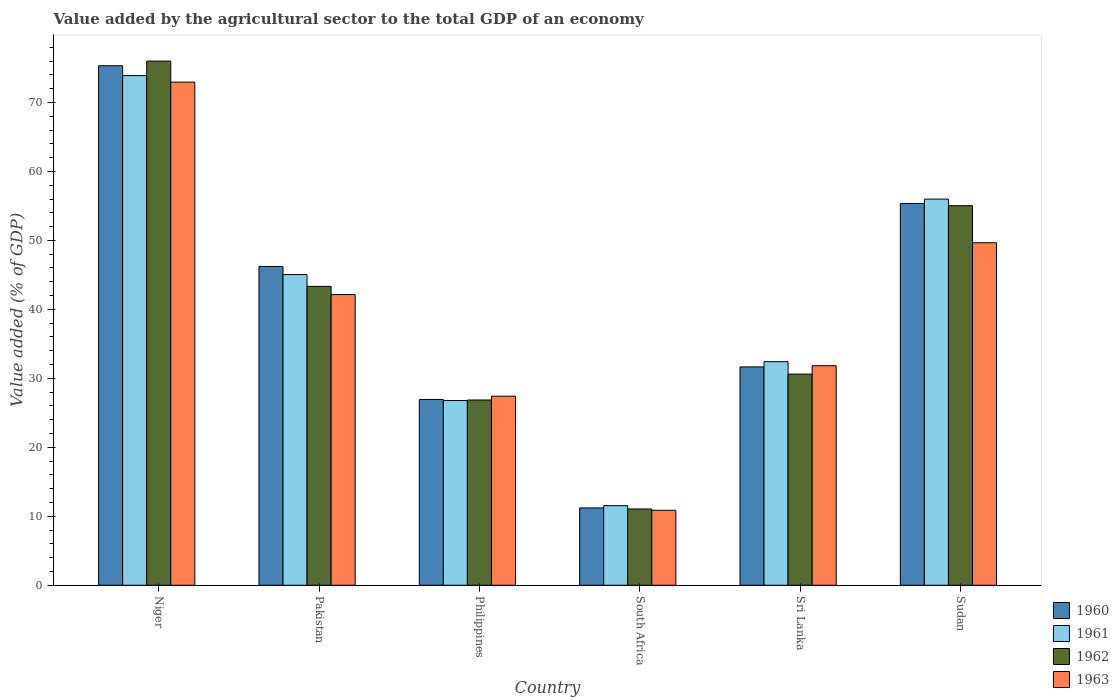Are the number of bars on each tick of the X-axis equal?
Give a very brief answer. Yes. How many bars are there on the 5th tick from the left?
Provide a short and direct response. 4. How many bars are there on the 6th tick from the right?
Your answer should be very brief. 4. What is the label of the 1st group of bars from the left?
Keep it short and to the point. Niger. What is the value added by the agricultural sector to the total GDP in 1961 in South Africa?
Provide a succinct answer. 11.54. Across all countries, what is the maximum value added by the agricultural sector to the total GDP in 1961?
Give a very brief answer. 73.89. Across all countries, what is the minimum value added by the agricultural sector to the total GDP in 1963?
Keep it short and to the point. 10.87. In which country was the value added by the agricultural sector to the total GDP in 1961 maximum?
Offer a very short reply. Niger. In which country was the value added by the agricultural sector to the total GDP in 1961 minimum?
Your answer should be compact. South Africa. What is the total value added by the agricultural sector to the total GDP in 1960 in the graph?
Offer a very short reply. 246.7. What is the difference between the value added by the agricultural sector to the total GDP in 1960 in Philippines and that in Sudan?
Offer a terse response. -28.41. What is the difference between the value added by the agricultural sector to the total GDP in 1961 in Pakistan and the value added by the agricultural sector to the total GDP in 1960 in South Africa?
Ensure brevity in your answer.  33.83. What is the average value added by the agricultural sector to the total GDP in 1961 per country?
Your answer should be very brief. 40.94. What is the difference between the value added by the agricultural sector to the total GDP of/in 1961 and value added by the agricultural sector to the total GDP of/in 1962 in Philippines?
Your answer should be compact. -0.08. In how many countries, is the value added by the agricultural sector to the total GDP in 1960 greater than 72 %?
Your answer should be compact. 1. What is the ratio of the value added by the agricultural sector to the total GDP in 1962 in Niger to that in Philippines?
Your answer should be very brief. 2.83. Is the difference between the value added by the agricultural sector to the total GDP in 1961 in Niger and Philippines greater than the difference between the value added by the agricultural sector to the total GDP in 1962 in Niger and Philippines?
Offer a very short reply. No. What is the difference between the highest and the second highest value added by the agricultural sector to the total GDP in 1963?
Keep it short and to the point. 23.29. What is the difference between the highest and the lowest value added by the agricultural sector to the total GDP in 1963?
Keep it short and to the point. 62.08. Is it the case that in every country, the sum of the value added by the agricultural sector to the total GDP in 1962 and value added by the agricultural sector to the total GDP in 1963 is greater than the sum of value added by the agricultural sector to the total GDP in 1961 and value added by the agricultural sector to the total GDP in 1960?
Give a very brief answer. No. How many countries are there in the graph?
Ensure brevity in your answer.  6. What is the difference between two consecutive major ticks on the Y-axis?
Your response must be concise. 10. Does the graph contain any zero values?
Provide a short and direct response. No. Does the graph contain grids?
Provide a short and direct response. No. How many legend labels are there?
Your response must be concise. 4. What is the title of the graph?
Your answer should be very brief. Value added by the agricultural sector to the total GDP of an economy. What is the label or title of the X-axis?
Provide a succinct answer. Country. What is the label or title of the Y-axis?
Ensure brevity in your answer.  Value added (% of GDP). What is the Value added (% of GDP) of 1960 in Niger?
Keep it short and to the point. 75.32. What is the Value added (% of GDP) of 1961 in Niger?
Offer a very short reply. 73.89. What is the Value added (% of GDP) in 1962 in Niger?
Offer a terse response. 76. What is the Value added (% of GDP) in 1963 in Niger?
Your response must be concise. 72.95. What is the Value added (% of GDP) in 1960 in Pakistan?
Offer a terse response. 46.22. What is the Value added (% of GDP) of 1961 in Pakistan?
Keep it short and to the point. 45.04. What is the Value added (% of GDP) in 1962 in Pakistan?
Offer a terse response. 43.33. What is the Value added (% of GDP) of 1963 in Pakistan?
Offer a very short reply. 42.15. What is the Value added (% of GDP) of 1960 in Philippines?
Your response must be concise. 26.94. What is the Value added (% of GDP) in 1961 in Philippines?
Your answer should be very brief. 26.78. What is the Value added (% of GDP) in 1962 in Philippines?
Offer a terse response. 26.86. What is the Value added (% of GDP) of 1963 in Philippines?
Provide a short and direct response. 27.41. What is the Value added (% of GDP) of 1960 in South Africa?
Keep it short and to the point. 11.21. What is the Value added (% of GDP) of 1961 in South Africa?
Your response must be concise. 11.54. What is the Value added (% of GDP) of 1962 in South Africa?
Your answer should be very brief. 11.06. What is the Value added (% of GDP) of 1963 in South Africa?
Make the answer very short. 10.87. What is the Value added (% of GDP) of 1960 in Sri Lanka?
Your answer should be compact. 31.66. What is the Value added (% of GDP) in 1961 in Sri Lanka?
Provide a succinct answer. 32.41. What is the Value added (% of GDP) of 1962 in Sri Lanka?
Make the answer very short. 30.61. What is the Value added (% of GDP) of 1963 in Sri Lanka?
Give a very brief answer. 31.83. What is the Value added (% of GDP) of 1960 in Sudan?
Give a very brief answer. 55.35. What is the Value added (% of GDP) of 1961 in Sudan?
Keep it short and to the point. 55.99. What is the Value added (% of GDP) of 1962 in Sudan?
Your response must be concise. 55.03. What is the Value added (% of GDP) in 1963 in Sudan?
Your answer should be very brief. 49.66. Across all countries, what is the maximum Value added (% of GDP) in 1960?
Provide a short and direct response. 75.32. Across all countries, what is the maximum Value added (% of GDP) of 1961?
Provide a succinct answer. 73.89. Across all countries, what is the maximum Value added (% of GDP) of 1962?
Offer a terse response. 76. Across all countries, what is the maximum Value added (% of GDP) of 1963?
Your answer should be compact. 72.95. Across all countries, what is the minimum Value added (% of GDP) of 1960?
Your response must be concise. 11.21. Across all countries, what is the minimum Value added (% of GDP) in 1961?
Make the answer very short. 11.54. Across all countries, what is the minimum Value added (% of GDP) in 1962?
Your answer should be very brief. 11.06. Across all countries, what is the minimum Value added (% of GDP) of 1963?
Provide a succinct answer. 10.87. What is the total Value added (% of GDP) of 1960 in the graph?
Offer a terse response. 246.7. What is the total Value added (% of GDP) of 1961 in the graph?
Ensure brevity in your answer.  245.64. What is the total Value added (% of GDP) of 1962 in the graph?
Provide a short and direct response. 242.89. What is the total Value added (% of GDP) of 1963 in the graph?
Provide a short and direct response. 234.86. What is the difference between the Value added (% of GDP) in 1960 in Niger and that in Pakistan?
Your answer should be very brief. 29.1. What is the difference between the Value added (% of GDP) in 1961 in Niger and that in Pakistan?
Your answer should be compact. 28.84. What is the difference between the Value added (% of GDP) of 1962 in Niger and that in Pakistan?
Make the answer very short. 32.66. What is the difference between the Value added (% of GDP) of 1963 in Niger and that in Pakistan?
Your answer should be very brief. 30.8. What is the difference between the Value added (% of GDP) of 1960 in Niger and that in Philippines?
Offer a terse response. 48.38. What is the difference between the Value added (% of GDP) of 1961 in Niger and that in Philippines?
Keep it short and to the point. 47.11. What is the difference between the Value added (% of GDP) of 1962 in Niger and that in Philippines?
Ensure brevity in your answer.  49.14. What is the difference between the Value added (% of GDP) of 1963 in Niger and that in Philippines?
Provide a succinct answer. 45.54. What is the difference between the Value added (% of GDP) of 1960 in Niger and that in South Africa?
Give a very brief answer. 64.11. What is the difference between the Value added (% of GDP) of 1961 in Niger and that in South Africa?
Offer a terse response. 62.35. What is the difference between the Value added (% of GDP) in 1962 in Niger and that in South Africa?
Your answer should be very brief. 64.94. What is the difference between the Value added (% of GDP) in 1963 in Niger and that in South Africa?
Your response must be concise. 62.08. What is the difference between the Value added (% of GDP) in 1960 in Niger and that in Sri Lanka?
Provide a succinct answer. 43.67. What is the difference between the Value added (% of GDP) in 1961 in Niger and that in Sri Lanka?
Your answer should be very brief. 41.48. What is the difference between the Value added (% of GDP) in 1962 in Niger and that in Sri Lanka?
Offer a very short reply. 45.38. What is the difference between the Value added (% of GDP) of 1963 in Niger and that in Sri Lanka?
Give a very brief answer. 41.12. What is the difference between the Value added (% of GDP) of 1960 in Niger and that in Sudan?
Ensure brevity in your answer.  19.97. What is the difference between the Value added (% of GDP) of 1961 in Niger and that in Sudan?
Your answer should be very brief. 17.9. What is the difference between the Value added (% of GDP) of 1962 in Niger and that in Sudan?
Offer a very short reply. 20.96. What is the difference between the Value added (% of GDP) of 1963 in Niger and that in Sudan?
Make the answer very short. 23.29. What is the difference between the Value added (% of GDP) in 1960 in Pakistan and that in Philippines?
Give a very brief answer. 19.28. What is the difference between the Value added (% of GDP) in 1961 in Pakistan and that in Philippines?
Your answer should be compact. 18.27. What is the difference between the Value added (% of GDP) of 1962 in Pakistan and that in Philippines?
Your response must be concise. 16.48. What is the difference between the Value added (% of GDP) of 1963 in Pakistan and that in Philippines?
Offer a very short reply. 14.73. What is the difference between the Value added (% of GDP) in 1960 in Pakistan and that in South Africa?
Your response must be concise. 35.01. What is the difference between the Value added (% of GDP) of 1961 in Pakistan and that in South Africa?
Make the answer very short. 33.51. What is the difference between the Value added (% of GDP) in 1962 in Pakistan and that in South Africa?
Make the answer very short. 32.28. What is the difference between the Value added (% of GDP) in 1963 in Pakistan and that in South Africa?
Make the answer very short. 31.28. What is the difference between the Value added (% of GDP) in 1960 in Pakistan and that in Sri Lanka?
Your response must be concise. 14.56. What is the difference between the Value added (% of GDP) of 1961 in Pakistan and that in Sri Lanka?
Give a very brief answer. 12.63. What is the difference between the Value added (% of GDP) of 1962 in Pakistan and that in Sri Lanka?
Make the answer very short. 12.72. What is the difference between the Value added (% of GDP) of 1963 in Pakistan and that in Sri Lanka?
Your response must be concise. 10.32. What is the difference between the Value added (% of GDP) of 1960 in Pakistan and that in Sudan?
Keep it short and to the point. -9.13. What is the difference between the Value added (% of GDP) of 1961 in Pakistan and that in Sudan?
Provide a succinct answer. -10.94. What is the difference between the Value added (% of GDP) of 1962 in Pakistan and that in Sudan?
Provide a succinct answer. -11.7. What is the difference between the Value added (% of GDP) of 1963 in Pakistan and that in Sudan?
Give a very brief answer. -7.51. What is the difference between the Value added (% of GDP) of 1960 in Philippines and that in South Africa?
Keep it short and to the point. 15.73. What is the difference between the Value added (% of GDP) in 1961 in Philippines and that in South Africa?
Keep it short and to the point. 15.24. What is the difference between the Value added (% of GDP) in 1962 in Philippines and that in South Africa?
Provide a short and direct response. 15.8. What is the difference between the Value added (% of GDP) of 1963 in Philippines and that in South Africa?
Provide a succinct answer. 16.54. What is the difference between the Value added (% of GDP) of 1960 in Philippines and that in Sri Lanka?
Your answer should be compact. -4.72. What is the difference between the Value added (% of GDP) of 1961 in Philippines and that in Sri Lanka?
Offer a very short reply. -5.63. What is the difference between the Value added (% of GDP) of 1962 in Philippines and that in Sri Lanka?
Your answer should be compact. -3.76. What is the difference between the Value added (% of GDP) of 1963 in Philippines and that in Sri Lanka?
Provide a short and direct response. -4.41. What is the difference between the Value added (% of GDP) of 1960 in Philippines and that in Sudan?
Provide a succinct answer. -28.41. What is the difference between the Value added (% of GDP) of 1961 in Philippines and that in Sudan?
Your response must be concise. -29.21. What is the difference between the Value added (% of GDP) of 1962 in Philippines and that in Sudan?
Your answer should be compact. -28.18. What is the difference between the Value added (% of GDP) of 1963 in Philippines and that in Sudan?
Offer a very short reply. -22.25. What is the difference between the Value added (% of GDP) of 1960 in South Africa and that in Sri Lanka?
Your response must be concise. -20.45. What is the difference between the Value added (% of GDP) in 1961 in South Africa and that in Sri Lanka?
Offer a terse response. -20.87. What is the difference between the Value added (% of GDP) in 1962 in South Africa and that in Sri Lanka?
Ensure brevity in your answer.  -19.56. What is the difference between the Value added (% of GDP) of 1963 in South Africa and that in Sri Lanka?
Offer a terse response. -20.96. What is the difference between the Value added (% of GDP) in 1960 in South Africa and that in Sudan?
Give a very brief answer. -44.14. What is the difference between the Value added (% of GDP) in 1961 in South Africa and that in Sudan?
Offer a terse response. -44.45. What is the difference between the Value added (% of GDP) in 1962 in South Africa and that in Sudan?
Offer a terse response. -43.98. What is the difference between the Value added (% of GDP) of 1963 in South Africa and that in Sudan?
Ensure brevity in your answer.  -38.79. What is the difference between the Value added (% of GDP) of 1960 in Sri Lanka and that in Sudan?
Provide a succinct answer. -23.7. What is the difference between the Value added (% of GDP) of 1961 in Sri Lanka and that in Sudan?
Give a very brief answer. -23.58. What is the difference between the Value added (% of GDP) of 1962 in Sri Lanka and that in Sudan?
Your answer should be compact. -24.42. What is the difference between the Value added (% of GDP) of 1963 in Sri Lanka and that in Sudan?
Offer a very short reply. -17.83. What is the difference between the Value added (% of GDP) of 1960 in Niger and the Value added (% of GDP) of 1961 in Pakistan?
Offer a terse response. 30.28. What is the difference between the Value added (% of GDP) of 1960 in Niger and the Value added (% of GDP) of 1962 in Pakistan?
Your answer should be very brief. 31.99. What is the difference between the Value added (% of GDP) of 1960 in Niger and the Value added (% of GDP) of 1963 in Pakistan?
Offer a very short reply. 33.18. What is the difference between the Value added (% of GDP) of 1961 in Niger and the Value added (% of GDP) of 1962 in Pakistan?
Provide a short and direct response. 30.55. What is the difference between the Value added (% of GDP) of 1961 in Niger and the Value added (% of GDP) of 1963 in Pakistan?
Give a very brief answer. 31.74. What is the difference between the Value added (% of GDP) in 1962 in Niger and the Value added (% of GDP) in 1963 in Pakistan?
Your response must be concise. 33.85. What is the difference between the Value added (% of GDP) of 1960 in Niger and the Value added (% of GDP) of 1961 in Philippines?
Your answer should be compact. 48.55. What is the difference between the Value added (% of GDP) of 1960 in Niger and the Value added (% of GDP) of 1962 in Philippines?
Provide a short and direct response. 48.47. What is the difference between the Value added (% of GDP) of 1960 in Niger and the Value added (% of GDP) of 1963 in Philippines?
Offer a very short reply. 47.91. What is the difference between the Value added (% of GDP) in 1961 in Niger and the Value added (% of GDP) in 1962 in Philippines?
Provide a short and direct response. 47.03. What is the difference between the Value added (% of GDP) of 1961 in Niger and the Value added (% of GDP) of 1963 in Philippines?
Your answer should be very brief. 46.48. What is the difference between the Value added (% of GDP) of 1962 in Niger and the Value added (% of GDP) of 1963 in Philippines?
Give a very brief answer. 48.59. What is the difference between the Value added (% of GDP) of 1960 in Niger and the Value added (% of GDP) of 1961 in South Africa?
Ensure brevity in your answer.  63.79. What is the difference between the Value added (% of GDP) in 1960 in Niger and the Value added (% of GDP) in 1962 in South Africa?
Offer a terse response. 64.27. What is the difference between the Value added (% of GDP) in 1960 in Niger and the Value added (% of GDP) in 1963 in South Africa?
Offer a very short reply. 64.46. What is the difference between the Value added (% of GDP) of 1961 in Niger and the Value added (% of GDP) of 1962 in South Africa?
Your answer should be compact. 62.83. What is the difference between the Value added (% of GDP) in 1961 in Niger and the Value added (% of GDP) in 1963 in South Africa?
Keep it short and to the point. 63.02. What is the difference between the Value added (% of GDP) of 1962 in Niger and the Value added (% of GDP) of 1963 in South Africa?
Make the answer very short. 65.13. What is the difference between the Value added (% of GDP) in 1960 in Niger and the Value added (% of GDP) in 1961 in Sri Lanka?
Provide a succinct answer. 42.91. What is the difference between the Value added (% of GDP) of 1960 in Niger and the Value added (% of GDP) of 1962 in Sri Lanka?
Your response must be concise. 44.71. What is the difference between the Value added (% of GDP) in 1960 in Niger and the Value added (% of GDP) in 1963 in Sri Lanka?
Make the answer very short. 43.5. What is the difference between the Value added (% of GDP) in 1961 in Niger and the Value added (% of GDP) in 1962 in Sri Lanka?
Your response must be concise. 43.27. What is the difference between the Value added (% of GDP) in 1961 in Niger and the Value added (% of GDP) in 1963 in Sri Lanka?
Offer a very short reply. 42.06. What is the difference between the Value added (% of GDP) of 1962 in Niger and the Value added (% of GDP) of 1963 in Sri Lanka?
Your answer should be compact. 44.17. What is the difference between the Value added (% of GDP) in 1960 in Niger and the Value added (% of GDP) in 1961 in Sudan?
Make the answer very short. 19.34. What is the difference between the Value added (% of GDP) in 1960 in Niger and the Value added (% of GDP) in 1962 in Sudan?
Provide a succinct answer. 20.29. What is the difference between the Value added (% of GDP) of 1960 in Niger and the Value added (% of GDP) of 1963 in Sudan?
Your answer should be very brief. 25.67. What is the difference between the Value added (% of GDP) of 1961 in Niger and the Value added (% of GDP) of 1962 in Sudan?
Your answer should be very brief. 18.85. What is the difference between the Value added (% of GDP) of 1961 in Niger and the Value added (% of GDP) of 1963 in Sudan?
Offer a very short reply. 24.23. What is the difference between the Value added (% of GDP) in 1962 in Niger and the Value added (% of GDP) in 1963 in Sudan?
Make the answer very short. 26.34. What is the difference between the Value added (% of GDP) in 1960 in Pakistan and the Value added (% of GDP) in 1961 in Philippines?
Provide a short and direct response. 19.44. What is the difference between the Value added (% of GDP) of 1960 in Pakistan and the Value added (% of GDP) of 1962 in Philippines?
Keep it short and to the point. 19.36. What is the difference between the Value added (% of GDP) in 1960 in Pakistan and the Value added (% of GDP) in 1963 in Philippines?
Your answer should be compact. 18.81. What is the difference between the Value added (% of GDP) in 1961 in Pakistan and the Value added (% of GDP) in 1962 in Philippines?
Offer a very short reply. 18.19. What is the difference between the Value added (% of GDP) of 1961 in Pakistan and the Value added (% of GDP) of 1963 in Philippines?
Give a very brief answer. 17.63. What is the difference between the Value added (% of GDP) of 1962 in Pakistan and the Value added (% of GDP) of 1963 in Philippines?
Give a very brief answer. 15.92. What is the difference between the Value added (% of GDP) of 1960 in Pakistan and the Value added (% of GDP) of 1961 in South Africa?
Ensure brevity in your answer.  34.68. What is the difference between the Value added (% of GDP) in 1960 in Pakistan and the Value added (% of GDP) in 1962 in South Africa?
Offer a terse response. 35.16. What is the difference between the Value added (% of GDP) of 1960 in Pakistan and the Value added (% of GDP) of 1963 in South Africa?
Your response must be concise. 35.35. What is the difference between the Value added (% of GDP) of 1961 in Pakistan and the Value added (% of GDP) of 1962 in South Africa?
Your answer should be very brief. 33.99. What is the difference between the Value added (% of GDP) of 1961 in Pakistan and the Value added (% of GDP) of 1963 in South Africa?
Keep it short and to the point. 34.17. What is the difference between the Value added (% of GDP) in 1962 in Pakistan and the Value added (% of GDP) in 1963 in South Africa?
Provide a succinct answer. 32.46. What is the difference between the Value added (% of GDP) in 1960 in Pakistan and the Value added (% of GDP) in 1961 in Sri Lanka?
Make the answer very short. 13.81. What is the difference between the Value added (% of GDP) of 1960 in Pakistan and the Value added (% of GDP) of 1962 in Sri Lanka?
Give a very brief answer. 15.61. What is the difference between the Value added (% of GDP) of 1960 in Pakistan and the Value added (% of GDP) of 1963 in Sri Lanka?
Your response must be concise. 14.39. What is the difference between the Value added (% of GDP) in 1961 in Pakistan and the Value added (% of GDP) in 1962 in Sri Lanka?
Offer a very short reply. 14.43. What is the difference between the Value added (% of GDP) in 1961 in Pakistan and the Value added (% of GDP) in 1963 in Sri Lanka?
Offer a very short reply. 13.22. What is the difference between the Value added (% of GDP) of 1962 in Pakistan and the Value added (% of GDP) of 1963 in Sri Lanka?
Offer a very short reply. 11.51. What is the difference between the Value added (% of GDP) in 1960 in Pakistan and the Value added (% of GDP) in 1961 in Sudan?
Offer a very short reply. -9.77. What is the difference between the Value added (% of GDP) of 1960 in Pakistan and the Value added (% of GDP) of 1962 in Sudan?
Offer a very short reply. -8.81. What is the difference between the Value added (% of GDP) in 1960 in Pakistan and the Value added (% of GDP) in 1963 in Sudan?
Your response must be concise. -3.44. What is the difference between the Value added (% of GDP) of 1961 in Pakistan and the Value added (% of GDP) of 1962 in Sudan?
Make the answer very short. -9.99. What is the difference between the Value added (% of GDP) in 1961 in Pakistan and the Value added (% of GDP) in 1963 in Sudan?
Provide a succinct answer. -4.62. What is the difference between the Value added (% of GDP) in 1962 in Pakistan and the Value added (% of GDP) in 1963 in Sudan?
Your answer should be compact. -6.33. What is the difference between the Value added (% of GDP) in 1960 in Philippines and the Value added (% of GDP) in 1961 in South Africa?
Your answer should be compact. 15.4. What is the difference between the Value added (% of GDP) in 1960 in Philippines and the Value added (% of GDP) in 1962 in South Africa?
Your answer should be very brief. 15.88. What is the difference between the Value added (% of GDP) of 1960 in Philippines and the Value added (% of GDP) of 1963 in South Africa?
Your answer should be compact. 16.07. What is the difference between the Value added (% of GDP) in 1961 in Philippines and the Value added (% of GDP) in 1962 in South Africa?
Ensure brevity in your answer.  15.72. What is the difference between the Value added (% of GDP) of 1961 in Philippines and the Value added (% of GDP) of 1963 in South Africa?
Provide a succinct answer. 15.91. What is the difference between the Value added (% of GDP) in 1962 in Philippines and the Value added (% of GDP) in 1963 in South Africa?
Keep it short and to the point. 15.99. What is the difference between the Value added (% of GDP) in 1960 in Philippines and the Value added (% of GDP) in 1961 in Sri Lanka?
Offer a terse response. -5.47. What is the difference between the Value added (% of GDP) of 1960 in Philippines and the Value added (% of GDP) of 1962 in Sri Lanka?
Provide a succinct answer. -3.67. What is the difference between the Value added (% of GDP) of 1960 in Philippines and the Value added (% of GDP) of 1963 in Sri Lanka?
Provide a succinct answer. -4.89. What is the difference between the Value added (% of GDP) in 1961 in Philippines and the Value added (% of GDP) in 1962 in Sri Lanka?
Give a very brief answer. -3.84. What is the difference between the Value added (% of GDP) in 1961 in Philippines and the Value added (% of GDP) in 1963 in Sri Lanka?
Give a very brief answer. -5.05. What is the difference between the Value added (% of GDP) in 1962 in Philippines and the Value added (% of GDP) in 1963 in Sri Lanka?
Your answer should be compact. -4.97. What is the difference between the Value added (% of GDP) of 1960 in Philippines and the Value added (% of GDP) of 1961 in Sudan?
Offer a very short reply. -29.05. What is the difference between the Value added (% of GDP) in 1960 in Philippines and the Value added (% of GDP) in 1962 in Sudan?
Offer a terse response. -28.09. What is the difference between the Value added (% of GDP) of 1960 in Philippines and the Value added (% of GDP) of 1963 in Sudan?
Provide a short and direct response. -22.72. What is the difference between the Value added (% of GDP) in 1961 in Philippines and the Value added (% of GDP) in 1962 in Sudan?
Ensure brevity in your answer.  -28.26. What is the difference between the Value added (% of GDP) of 1961 in Philippines and the Value added (% of GDP) of 1963 in Sudan?
Offer a terse response. -22.88. What is the difference between the Value added (% of GDP) of 1962 in Philippines and the Value added (% of GDP) of 1963 in Sudan?
Your answer should be very brief. -22.8. What is the difference between the Value added (% of GDP) of 1960 in South Africa and the Value added (% of GDP) of 1961 in Sri Lanka?
Give a very brief answer. -21.2. What is the difference between the Value added (% of GDP) of 1960 in South Africa and the Value added (% of GDP) of 1962 in Sri Lanka?
Give a very brief answer. -19.4. What is the difference between the Value added (% of GDP) in 1960 in South Africa and the Value added (% of GDP) in 1963 in Sri Lanka?
Ensure brevity in your answer.  -20.62. What is the difference between the Value added (% of GDP) of 1961 in South Africa and the Value added (% of GDP) of 1962 in Sri Lanka?
Provide a short and direct response. -19.08. What is the difference between the Value added (% of GDP) in 1961 in South Africa and the Value added (% of GDP) in 1963 in Sri Lanka?
Your answer should be compact. -20.29. What is the difference between the Value added (% of GDP) of 1962 in South Africa and the Value added (% of GDP) of 1963 in Sri Lanka?
Your answer should be compact. -20.77. What is the difference between the Value added (% of GDP) of 1960 in South Africa and the Value added (% of GDP) of 1961 in Sudan?
Provide a short and direct response. -44.78. What is the difference between the Value added (% of GDP) in 1960 in South Africa and the Value added (% of GDP) in 1962 in Sudan?
Keep it short and to the point. -43.82. What is the difference between the Value added (% of GDP) in 1960 in South Africa and the Value added (% of GDP) in 1963 in Sudan?
Make the answer very short. -38.45. What is the difference between the Value added (% of GDP) of 1961 in South Africa and the Value added (% of GDP) of 1962 in Sudan?
Your answer should be compact. -43.5. What is the difference between the Value added (% of GDP) of 1961 in South Africa and the Value added (% of GDP) of 1963 in Sudan?
Make the answer very short. -38.12. What is the difference between the Value added (% of GDP) in 1962 in South Africa and the Value added (% of GDP) in 1963 in Sudan?
Give a very brief answer. -38.6. What is the difference between the Value added (% of GDP) in 1960 in Sri Lanka and the Value added (% of GDP) in 1961 in Sudan?
Provide a short and direct response. -24.33. What is the difference between the Value added (% of GDP) of 1960 in Sri Lanka and the Value added (% of GDP) of 1962 in Sudan?
Provide a short and direct response. -23.38. What is the difference between the Value added (% of GDP) of 1960 in Sri Lanka and the Value added (% of GDP) of 1963 in Sudan?
Keep it short and to the point. -18. What is the difference between the Value added (% of GDP) in 1961 in Sri Lanka and the Value added (% of GDP) in 1962 in Sudan?
Ensure brevity in your answer.  -22.62. What is the difference between the Value added (% of GDP) of 1961 in Sri Lanka and the Value added (% of GDP) of 1963 in Sudan?
Keep it short and to the point. -17.25. What is the difference between the Value added (% of GDP) in 1962 in Sri Lanka and the Value added (% of GDP) in 1963 in Sudan?
Your response must be concise. -19.04. What is the average Value added (% of GDP) in 1960 per country?
Ensure brevity in your answer.  41.12. What is the average Value added (% of GDP) in 1961 per country?
Your answer should be very brief. 40.94. What is the average Value added (% of GDP) in 1962 per country?
Make the answer very short. 40.48. What is the average Value added (% of GDP) of 1963 per country?
Provide a short and direct response. 39.14. What is the difference between the Value added (% of GDP) in 1960 and Value added (% of GDP) in 1961 in Niger?
Provide a succinct answer. 1.44. What is the difference between the Value added (% of GDP) in 1960 and Value added (% of GDP) in 1962 in Niger?
Your answer should be compact. -0.67. What is the difference between the Value added (% of GDP) of 1960 and Value added (% of GDP) of 1963 in Niger?
Your response must be concise. 2.38. What is the difference between the Value added (% of GDP) of 1961 and Value added (% of GDP) of 1962 in Niger?
Offer a very short reply. -2.11. What is the difference between the Value added (% of GDP) in 1961 and Value added (% of GDP) in 1963 in Niger?
Make the answer very short. 0.94. What is the difference between the Value added (% of GDP) of 1962 and Value added (% of GDP) of 1963 in Niger?
Your answer should be compact. 3.05. What is the difference between the Value added (% of GDP) of 1960 and Value added (% of GDP) of 1961 in Pakistan?
Keep it short and to the point. 1.18. What is the difference between the Value added (% of GDP) of 1960 and Value added (% of GDP) of 1962 in Pakistan?
Provide a short and direct response. 2.89. What is the difference between the Value added (% of GDP) in 1960 and Value added (% of GDP) in 1963 in Pakistan?
Your answer should be very brief. 4.07. What is the difference between the Value added (% of GDP) of 1961 and Value added (% of GDP) of 1962 in Pakistan?
Your answer should be very brief. 1.71. What is the difference between the Value added (% of GDP) of 1961 and Value added (% of GDP) of 1963 in Pakistan?
Make the answer very short. 2.9. What is the difference between the Value added (% of GDP) of 1962 and Value added (% of GDP) of 1963 in Pakistan?
Your response must be concise. 1.19. What is the difference between the Value added (% of GDP) of 1960 and Value added (% of GDP) of 1961 in Philippines?
Give a very brief answer. 0.16. What is the difference between the Value added (% of GDP) in 1960 and Value added (% of GDP) in 1962 in Philippines?
Offer a very short reply. 0.08. What is the difference between the Value added (% of GDP) in 1960 and Value added (% of GDP) in 1963 in Philippines?
Provide a succinct answer. -0.47. What is the difference between the Value added (% of GDP) in 1961 and Value added (% of GDP) in 1962 in Philippines?
Your response must be concise. -0.08. What is the difference between the Value added (% of GDP) in 1961 and Value added (% of GDP) in 1963 in Philippines?
Provide a short and direct response. -0.64. What is the difference between the Value added (% of GDP) in 1962 and Value added (% of GDP) in 1963 in Philippines?
Provide a succinct answer. -0.55. What is the difference between the Value added (% of GDP) of 1960 and Value added (% of GDP) of 1961 in South Africa?
Your answer should be very brief. -0.33. What is the difference between the Value added (% of GDP) in 1960 and Value added (% of GDP) in 1962 in South Africa?
Your answer should be very brief. 0.15. What is the difference between the Value added (% of GDP) in 1960 and Value added (% of GDP) in 1963 in South Africa?
Provide a short and direct response. 0.34. What is the difference between the Value added (% of GDP) in 1961 and Value added (% of GDP) in 1962 in South Africa?
Your answer should be very brief. 0.48. What is the difference between the Value added (% of GDP) in 1961 and Value added (% of GDP) in 1963 in South Africa?
Your answer should be very brief. 0.67. What is the difference between the Value added (% of GDP) in 1962 and Value added (% of GDP) in 1963 in South Africa?
Your answer should be compact. 0.19. What is the difference between the Value added (% of GDP) of 1960 and Value added (% of GDP) of 1961 in Sri Lanka?
Ensure brevity in your answer.  -0.76. What is the difference between the Value added (% of GDP) in 1960 and Value added (% of GDP) in 1962 in Sri Lanka?
Ensure brevity in your answer.  1.04. What is the difference between the Value added (% of GDP) in 1960 and Value added (% of GDP) in 1963 in Sri Lanka?
Offer a terse response. -0.17. What is the difference between the Value added (% of GDP) in 1961 and Value added (% of GDP) in 1962 in Sri Lanka?
Your answer should be compact. 1.8. What is the difference between the Value added (% of GDP) of 1961 and Value added (% of GDP) of 1963 in Sri Lanka?
Your answer should be very brief. 0.59. What is the difference between the Value added (% of GDP) in 1962 and Value added (% of GDP) in 1963 in Sri Lanka?
Offer a very short reply. -1.21. What is the difference between the Value added (% of GDP) in 1960 and Value added (% of GDP) in 1961 in Sudan?
Ensure brevity in your answer.  -0.64. What is the difference between the Value added (% of GDP) of 1960 and Value added (% of GDP) of 1962 in Sudan?
Offer a very short reply. 0.32. What is the difference between the Value added (% of GDP) in 1960 and Value added (% of GDP) in 1963 in Sudan?
Make the answer very short. 5.69. What is the difference between the Value added (% of GDP) in 1961 and Value added (% of GDP) in 1962 in Sudan?
Provide a succinct answer. 0.95. What is the difference between the Value added (% of GDP) in 1961 and Value added (% of GDP) in 1963 in Sudan?
Provide a short and direct response. 6.33. What is the difference between the Value added (% of GDP) of 1962 and Value added (% of GDP) of 1963 in Sudan?
Make the answer very short. 5.37. What is the ratio of the Value added (% of GDP) in 1960 in Niger to that in Pakistan?
Give a very brief answer. 1.63. What is the ratio of the Value added (% of GDP) in 1961 in Niger to that in Pakistan?
Make the answer very short. 1.64. What is the ratio of the Value added (% of GDP) in 1962 in Niger to that in Pakistan?
Your answer should be compact. 1.75. What is the ratio of the Value added (% of GDP) in 1963 in Niger to that in Pakistan?
Your response must be concise. 1.73. What is the ratio of the Value added (% of GDP) in 1960 in Niger to that in Philippines?
Offer a very short reply. 2.8. What is the ratio of the Value added (% of GDP) in 1961 in Niger to that in Philippines?
Provide a succinct answer. 2.76. What is the ratio of the Value added (% of GDP) of 1962 in Niger to that in Philippines?
Offer a very short reply. 2.83. What is the ratio of the Value added (% of GDP) in 1963 in Niger to that in Philippines?
Give a very brief answer. 2.66. What is the ratio of the Value added (% of GDP) in 1960 in Niger to that in South Africa?
Ensure brevity in your answer.  6.72. What is the ratio of the Value added (% of GDP) in 1961 in Niger to that in South Africa?
Provide a succinct answer. 6.4. What is the ratio of the Value added (% of GDP) in 1962 in Niger to that in South Africa?
Your answer should be compact. 6.87. What is the ratio of the Value added (% of GDP) in 1963 in Niger to that in South Africa?
Provide a succinct answer. 6.71. What is the ratio of the Value added (% of GDP) in 1960 in Niger to that in Sri Lanka?
Provide a succinct answer. 2.38. What is the ratio of the Value added (% of GDP) of 1961 in Niger to that in Sri Lanka?
Make the answer very short. 2.28. What is the ratio of the Value added (% of GDP) in 1962 in Niger to that in Sri Lanka?
Ensure brevity in your answer.  2.48. What is the ratio of the Value added (% of GDP) in 1963 in Niger to that in Sri Lanka?
Provide a succinct answer. 2.29. What is the ratio of the Value added (% of GDP) of 1960 in Niger to that in Sudan?
Make the answer very short. 1.36. What is the ratio of the Value added (% of GDP) of 1961 in Niger to that in Sudan?
Ensure brevity in your answer.  1.32. What is the ratio of the Value added (% of GDP) of 1962 in Niger to that in Sudan?
Offer a terse response. 1.38. What is the ratio of the Value added (% of GDP) of 1963 in Niger to that in Sudan?
Ensure brevity in your answer.  1.47. What is the ratio of the Value added (% of GDP) in 1960 in Pakistan to that in Philippines?
Offer a terse response. 1.72. What is the ratio of the Value added (% of GDP) in 1961 in Pakistan to that in Philippines?
Make the answer very short. 1.68. What is the ratio of the Value added (% of GDP) in 1962 in Pakistan to that in Philippines?
Your response must be concise. 1.61. What is the ratio of the Value added (% of GDP) in 1963 in Pakistan to that in Philippines?
Offer a terse response. 1.54. What is the ratio of the Value added (% of GDP) in 1960 in Pakistan to that in South Africa?
Your response must be concise. 4.12. What is the ratio of the Value added (% of GDP) of 1961 in Pakistan to that in South Africa?
Make the answer very short. 3.9. What is the ratio of the Value added (% of GDP) in 1962 in Pakistan to that in South Africa?
Offer a very short reply. 3.92. What is the ratio of the Value added (% of GDP) in 1963 in Pakistan to that in South Africa?
Your response must be concise. 3.88. What is the ratio of the Value added (% of GDP) of 1960 in Pakistan to that in Sri Lanka?
Provide a succinct answer. 1.46. What is the ratio of the Value added (% of GDP) in 1961 in Pakistan to that in Sri Lanka?
Your answer should be compact. 1.39. What is the ratio of the Value added (% of GDP) in 1962 in Pakistan to that in Sri Lanka?
Ensure brevity in your answer.  1.42. What is the ratio of the Value added (% of GDP) in 1963 in Pakistan to that in Sri Lanka?
Provide a short and direct response. 1.32. What is the ratio of the Value added (% of GDP) of 1960 in Pakistan to that in Sudan?
Keep it short and to the point. 0.83. What is the ratio of the Value added (% of GDP) of 1961 in Pakistan to that in Sudan?
Provide a succinct answer. 0.8. What is the ratio of the Value added (% of GDP) of 1962 in Pakistan to that in Sudan?
Give a very brief answer. 0.79. What is the ratio of the Value added (% of GDP) in 1963 in Pakistan to that in Sudan?
Keep it short and to the point. 0.85. What is the ratio of the Value added (% of GDP) in 1960 in Philippines to that in South Africa?
Your answer should be very brief. 2.4. What is the ratio of the Value added (% of GDP) in 1961 in Philippines to that in South Africa?
Give a very brief answer. 2.32. What is the ratio of the Value added (% of GDP) of 1962 in Philippines to that in South Africa?
Provide a succinct answer. 2.43. What is the ratio of the Value added (% of GDP) of 1963 in Philippines to that in South Africa?
Your response must be concise. 2.52. What is the ratio of the Value added (% of GDP) in 1960 in Philippines to that in Sri Lanka?
Offer a very short reply. 0.85. What is the ratio of the Value added (% of GDP) in 1961 in Philippines to that in Sri Lanka?
Give a very brief answer. 0.83. What is the ratio of the Value added (% of GDP) of 1962 in Philippines to that in Sri Lanka?
Your answer should be compact. 0.88. What is the ratio of the Value added (% of GDP) in 1963 in Philippines to that in Sri Lanka?
Provide a succinct answer. 0.86. What is the ratio of the Value added (% of GDP) of 1960 in Philippines to that in Sudan?
Offer a terse response. 0.49. What is the ratio of the Value added (% of GDP) in 1961 in Philippines to that in Sudan?
Give a very brief answer. 0.48. What is the ratio of the Value added (% of GDP) of 1962 in Philippines to that in Sudan?
Give a very brief answer. 0.49. What is the ratio of the Value added (% of GDP) in 1963 in Philippines to that in Sudan?
Your answer should be compact. 0.55. What is the ratio of the Value added (% of GDP) of 1960 in South Africa to that in Sri Lanka?
Make the answer very short. 0.35. What is the ratio of the Value added (% of GDP) of 1961 in South Africa to that in Sri Lanka?
Provide a short and direct response. 0.36. What is the ratio of the Value added (% of GDP) in 1962 in South Africa to that in Sri Lanka?
Your answer should be compact. 0.36. What is the ratio of the Value added (% of GDP) of 1963 in South Africa to that in Sri Lanka?
Your answer should be very brief. 0.34. What is the ratio of the Value added (% of GDP) in 1960 in South Africa to that in Sudan?
Provide a short and direct response. 0.2. What is the ratio of the Value added (% of GDP) in 1961 in South Africa to that in Sudan?
Provide a short and direct response. 0.21. What is the ratio of the Value added (% of GDP) in 1962 in South Africa to that in Sudan?
Keep it short and to the point. 0.2. What is the ratio of the Value added (% of GDP) in 1963 in South Africa to that in Sudan?
Your answer should be compact. 0.22. What is the ratio of the Value added (% of GDP) of 1960 in Sri Lanka to that in Sudan?
Offer a very short reply. 0.57. What is the ratio of the Value added (% of GDP) of 1961 in Sri Lanka to that in Sudan?
Your answer should be compact. 0.58. What is the ratio of the Value added (% of GDP) of 1962 in Sri Lanka to that in Sudan?
Your answer should be compact. 0.56. What is the ratio of the Value added (% of GDP) in 1963 in Sri Lanka to that in Sudan?
Provide a succinct answer. 0.64. What is the difference between the highest and the second highest Value added (% of GDP) in 1960?
Make the answer very short. 19.97. What is the difference between the highest and the second highest Value added (% of GDP) of 1961?
Keep it short and to the point. 17.9. What is the difference between the highest and the second highest Value added (% of GDP) in 1962?
Ensure brevity in your answer.  20.96. What is the difference between the highest and the second highest Value added (% of GDP) in 1963?
Offer a terse response. 23.29. What is the difference between the highest and the lowest Value added (% of GDP) of 1960?
Provide a succinct answer. 64.11. What is the difference between the highest and the lowest Value added (% of GDP) of 1961?
Your response must be concise. 62.35. What is the difference between the highest and the lowest Value added (% of GDP) of 1962?
Your answer should be compact. 64.94. What is the difference between the highest and the lowest Value added (% of GDP) in 1963?
Offer a terse response. 62.08. 